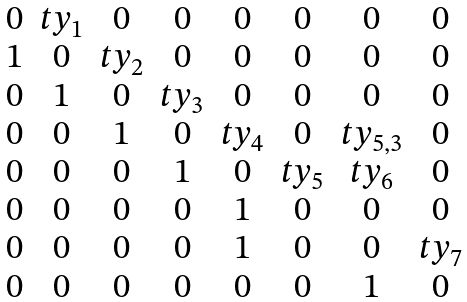<formula> <loc_0><loc_0><loc_500><loc_500>\begin{matrix} 0 & t y _ { 1 } & 0 & 0 & 0 & 0 & 0 & 0 \\ 1 & 0 & t y _ { 2 } & 0 & 0 & 0 & 0 & 0 \\ 0 & 1 & 0 & t y _ { 3 } & 0 & 0 & 0 & 0 \\ 0 & 0 & 1 & 0 & t y _ { 4 } & 0 & t y _ { 5 , 3 } & 0 \\ 0 & 0 & 0 & 1 & 0 & t y _ { 5 } & t y _ { 6 } & 0 \\ 0 & 0 & 0 & 0 & 1 & 0 & 0 & 0 \\ 0 & 0 & 0 & 0 & 1 & 0 & 0 & t y _ { 7 } \\ 0 & 0 & 0 & 0 & 0 & 0 & 1 & 0 \end{matrix}</formula> 